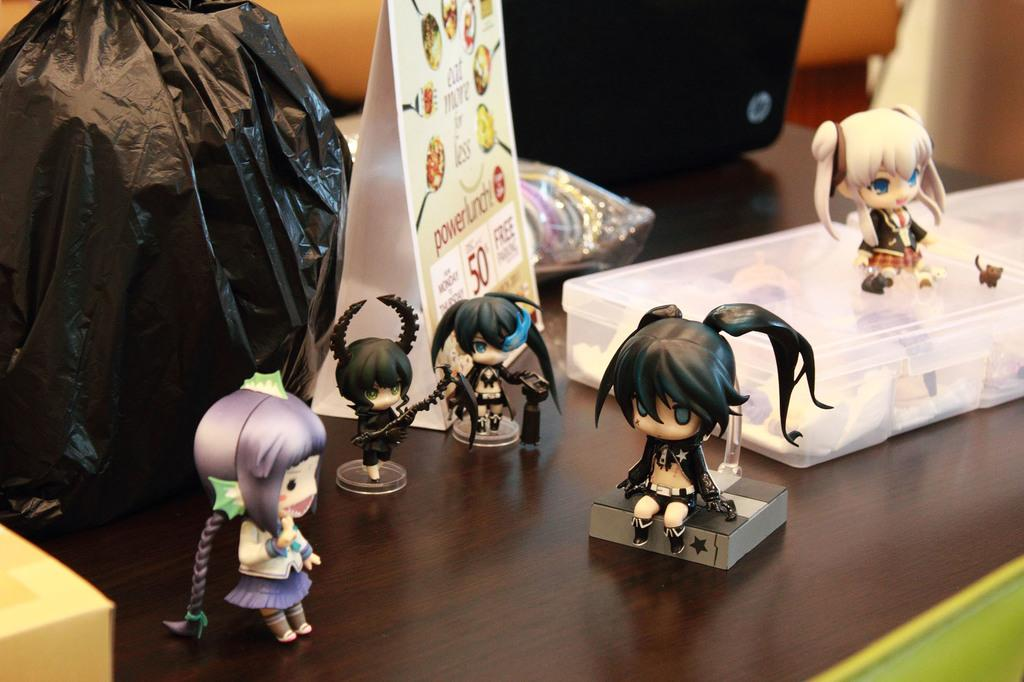What is the color and material of the table in the image? The table in the image is brown and made of wood. What items can be seen on the table? There are toys, a plastic box, a laptop, a carry bag, a wooden box, and a car in the shape of a triangle on the table. What type of car is on the table? The car on the table is in the shape of a triangle. Where is the chicken sitting on the table in the image? There is no chicken present in the image. What type of lamp is on the table in the image? There is no lamp present in the image. 